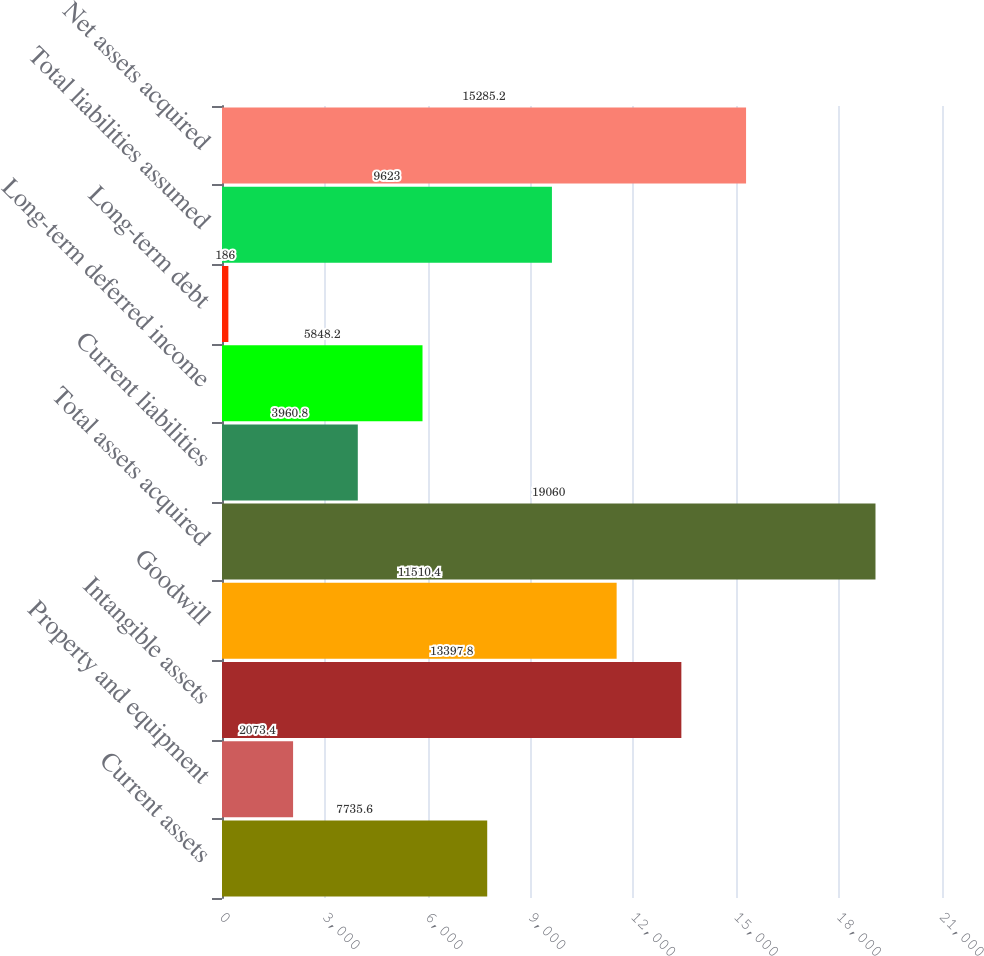Convert chart. <chart><loc_0><loc_0><loc_500><loc_500><bar_chart><fcel>Current assets<fcel>Property and equipment<fcel>Intangible assets<fcel>Goodwill<fcel>Total assets acquired<fcel>Current liabilities<fcel>Long-term deferred income<fcel>Long-term debt<fcel>Total liabilities assumed<fcel>Net assets acquired<nl><fcel>7735.6<fcel>2073.4<fcel>13397.8<fcel>11510.4<fcel>19060<fcel>3960.8<fcel>5848.2<fcel>186<fcel>9623<fcel>15285.2<nl></chart> 